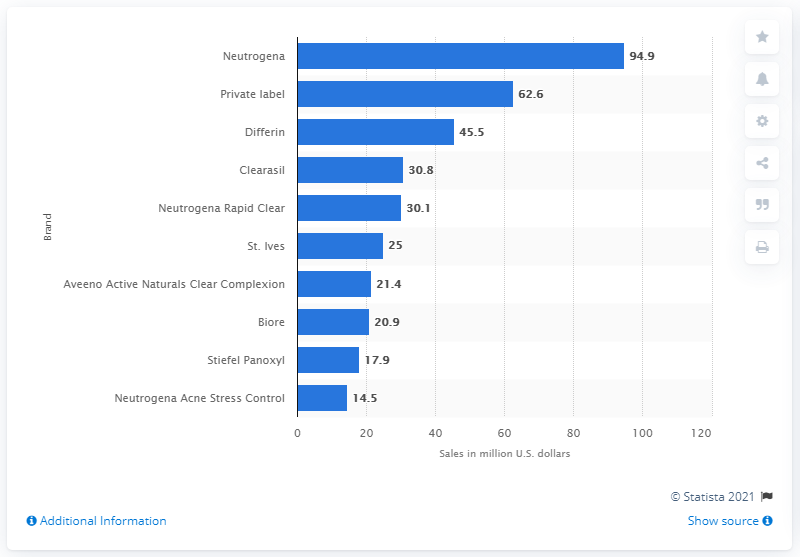Identify some key points in this picture. Neutrogena's sales in the United States in 2019 were $94.9 million. In 2019, Neutrogena was the leading acne treatment brand in the United States. 